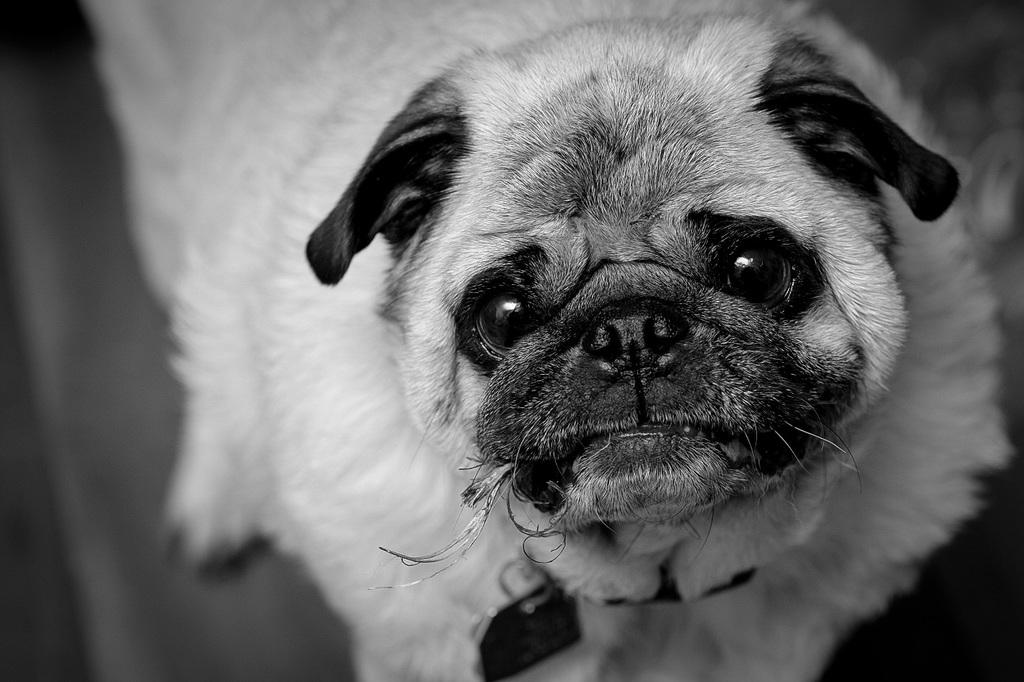What is the color scheme of the image? The image is black and white. What type of animal can be seen in the image? There is a dog in the image. What type of spark can be seen on the dog's haircut in the image? There is no spark or haircut visible in the image; it only features a dog in a black and white setting. 